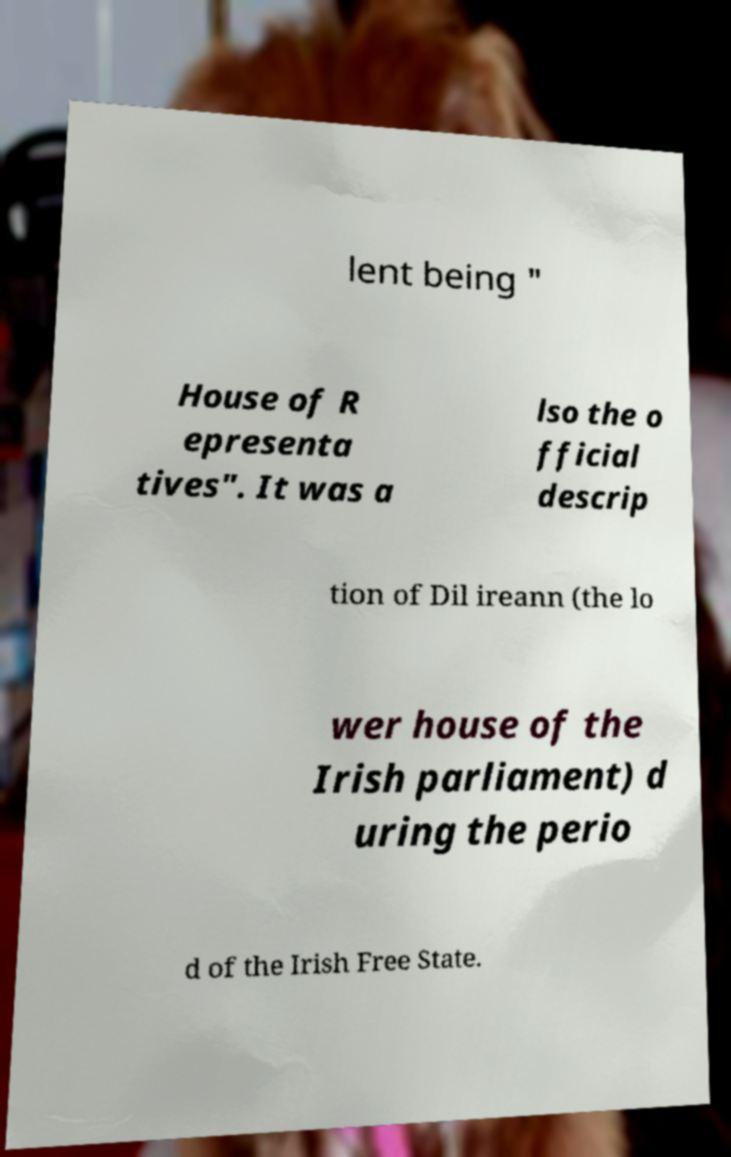Could you extract and type out the text from this image? lent being " House of R epresenta tives". It was a lso the o fficial descrip tion of Dil ireann (the lo wer house of the Irish parliament) d uring the perio d of the Irish Free State. 